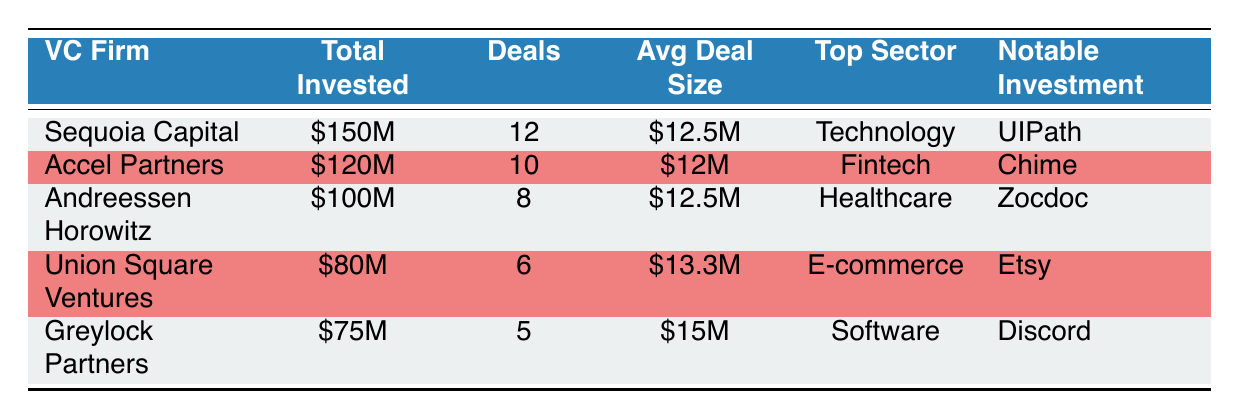What is the total amount invested by Sequoia Capital in NYC startups? Sequoia Capital has invested a total of 150 million dollars in NYC startups, as indicated in the table.
Answer: 150 million dollars Which venture capital firm has the highest average deal size? Greylock Partners has the highest average deal size listed at 15 million dollars, compared to the other firms where the highest average is 13.3 million dollars.
Answer: Greylock Partners How many deals did Accel Partners complete? Accel Partners is noted in the table to have completed 10 deals, as specified in that column.
Answer: 10 deals True or False: Union Square Ventures invested more than Greylock Partners. The total investment by Union Square Ventures is 80 million dollars while Greylock Partners invested 75 million dollars, which means Union Square Ventures invested more.
Answer: True What is the total combined investment of the top three venture capital firms? The total investment of the top three firms (Sequoia Capital, Accel Partners, and Andreessen Horowitz) is: 150 million + 120 million + 100 million = 370 million dollars.
Answer: 370 million dollars Which sector received the highest investment from Greylock Partners? Greylock Partners' top sector is listed as Software in the table, identifying what area their notable investments were focused on.
Answer: Software How many more deals did Sequoia Capital complete compared to Greylock Partners? Sequoia Capital completed 12 deals while Greylock Partners completed 5 deals. Doing the subtraction gives: 12 - 5 = 7 more deals.
Answer: 7 more deals True or False: Chime was a notable investment for Andreessen Horowitz. The table specifies Chime as a notable investment for Accel Partners, not Andreessen Horowitz, who had Zocdoc as their notable investment. Therefore, it is false.
Answer: False 